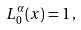Convert formula to latex. <formula><loc_0><loc_0><loc_500><loc_500>L _ { 0 } ^ { \alpha } ( x ) = 1 \, ,</formula> 